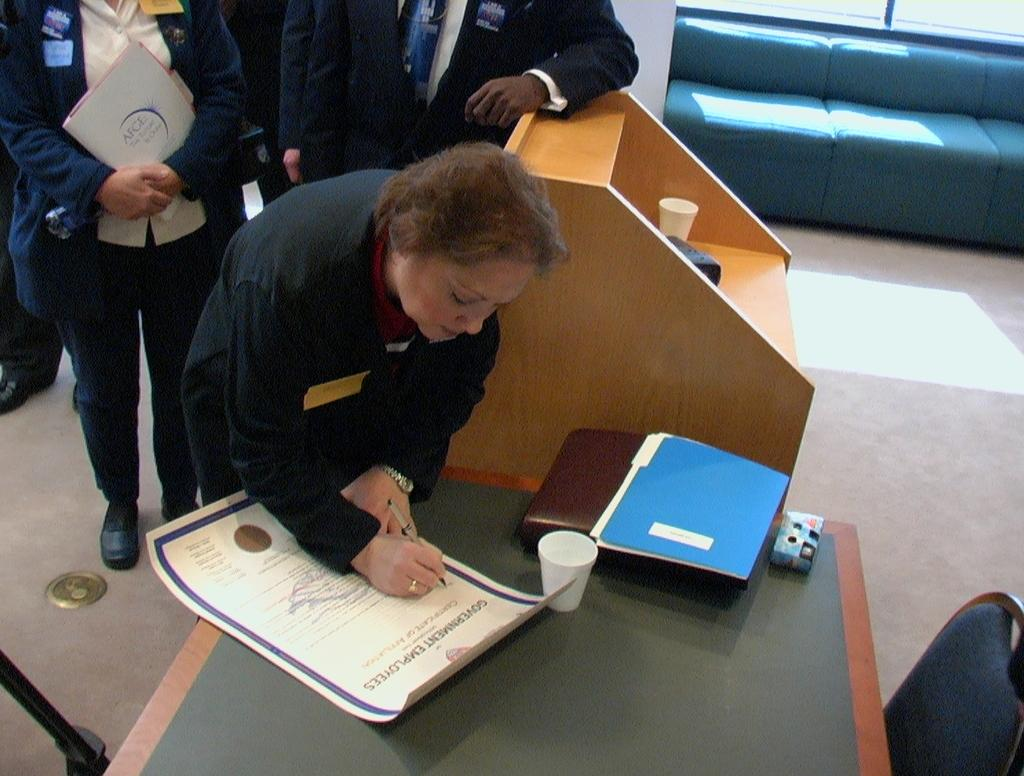How many people are in the image? There are persons in the image, but the exact number is not specified. What is one person doing in the image? One person is writing on a paper. What is on the table in the image? There is a cup and a file on the table. What type of furniture is present in the image? There is a chair and a sofa in the image. What is the surface on which the furniture is placed? There is a floor in the image. What type of destruction can be seen in the image? There is no destruction present in the image. What effect does the writing on the paper have on the cup? The writing on the paper does not have any effect on the cup, as they are separate objects in the image. 